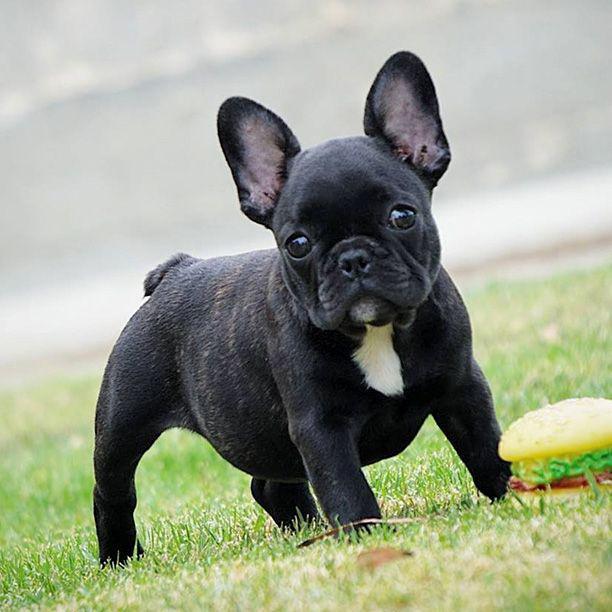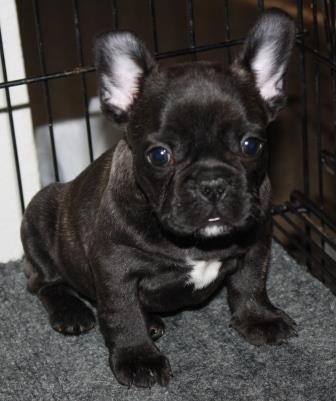The first image is the image on the left, the second image is the image on the right. Evaluate the accuracy of this statement regarding the images: "A single French Bulldog is standing up in the grass.". Is it true? Answer yes or no. Yes. 